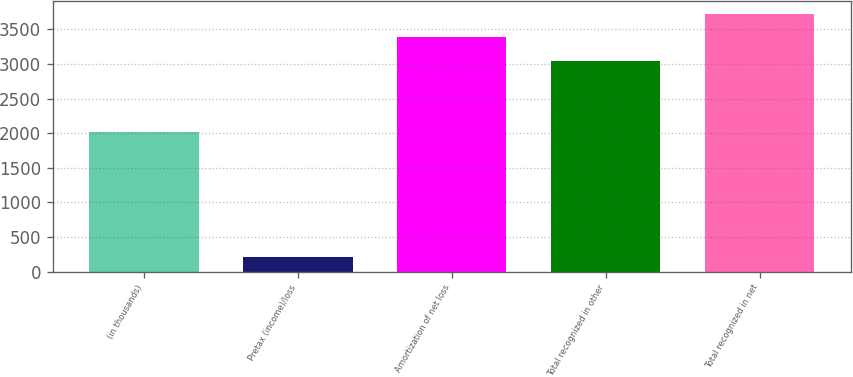Convert chart. <chart><loc_0><loc_0><loc_500><loc_500><bar_chart><fcel>(in thousands)<fcel>Pretax (income)/loss<fcel>Amortization of net loss<fcel>Total recognized in other<fcel>Total recognized in net<nl><fcel>2016<fcel>218<fcel>3383.1<fcel>3045<fcel>3721.2<nl></chart> 